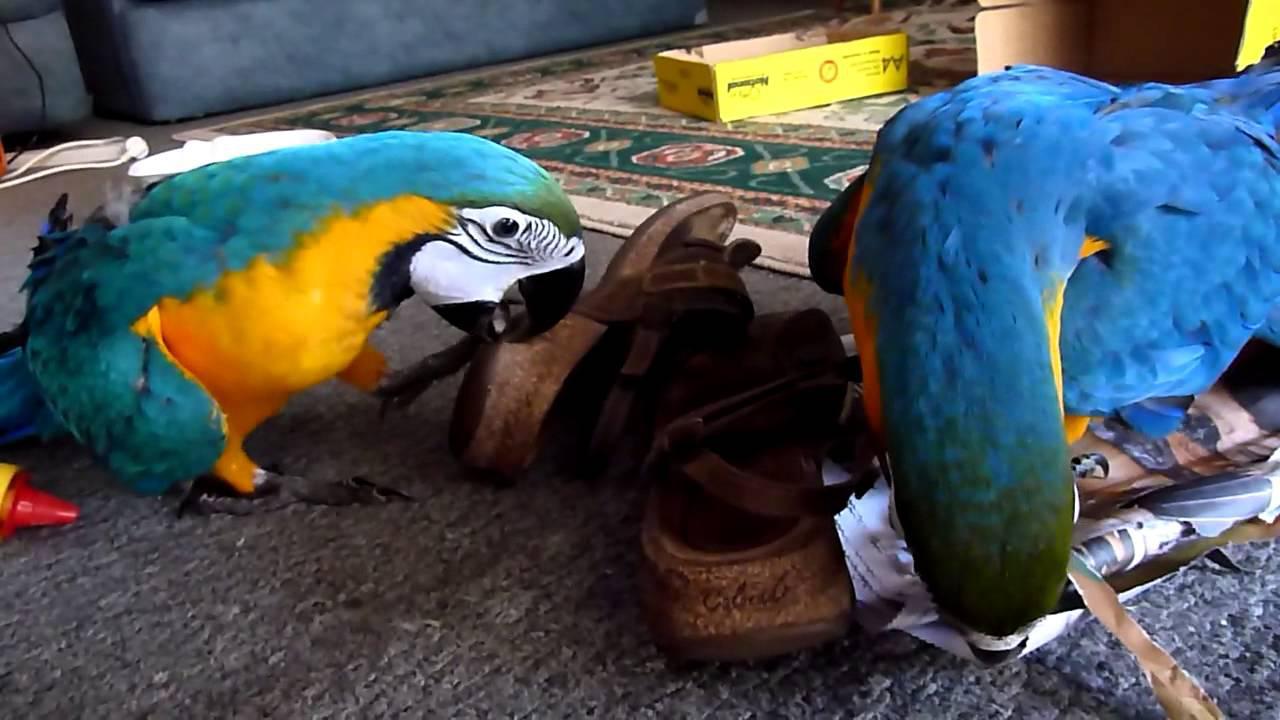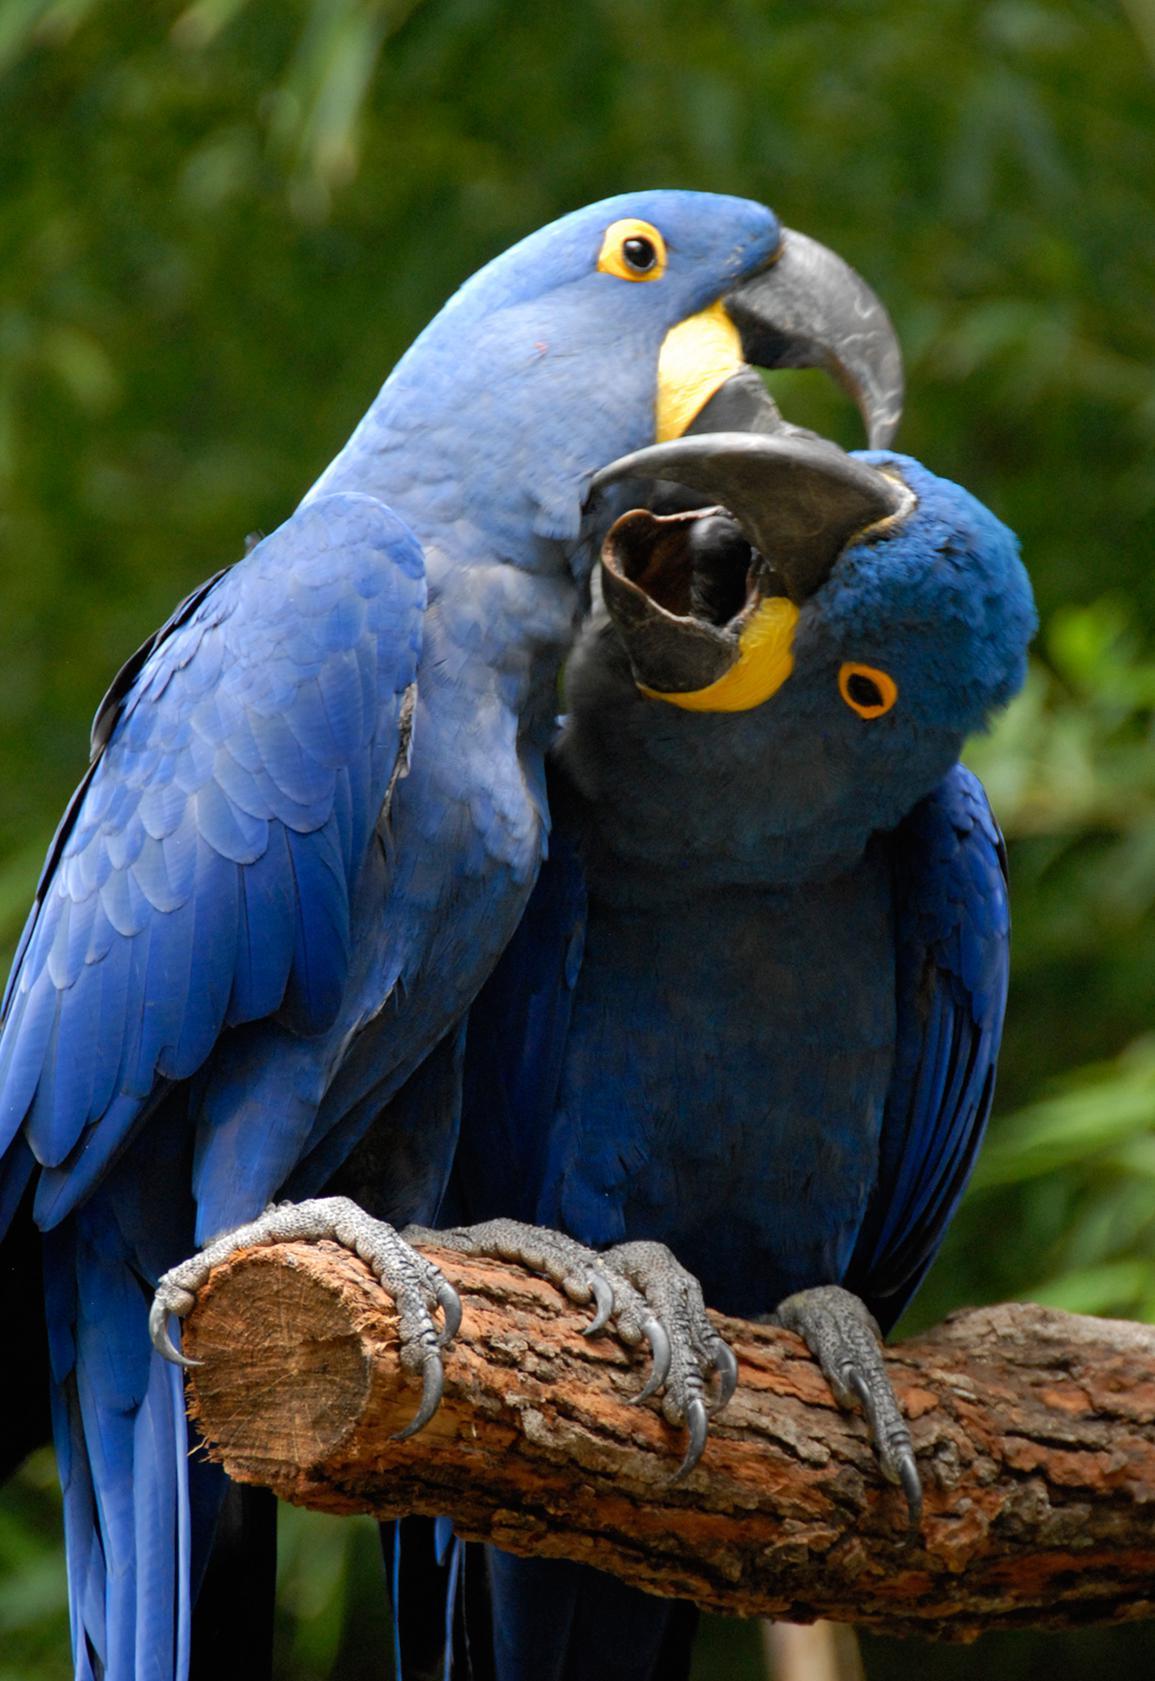The first image is the image on the left, the second image is the image on the right. Given the left and right images, does the statement "Two parrots nuzzle, in the image on the right." hold true? Answer yes or no. Yes. The first image is the image on the left, the second image is the image on the right. Given the left and right images, does the statement "All birds shown have blue and yellow coloring, and at least one bird has its yellow belly facing the camera." hold true? Answer yes or no. No. 